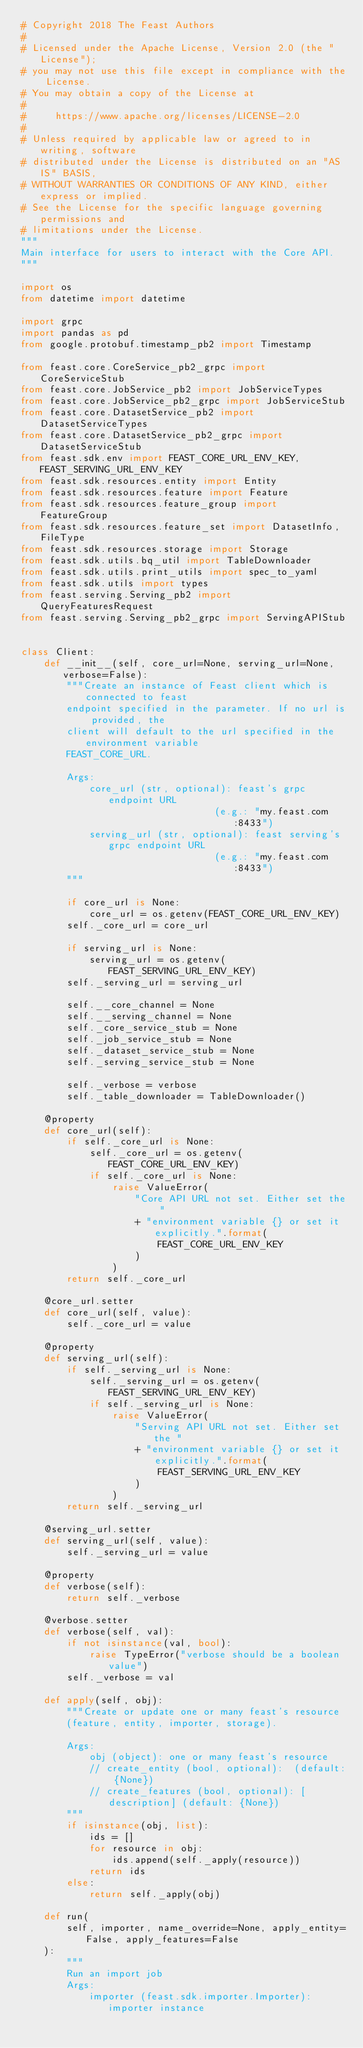Convert code to text. <code><loc_0><loc_0><loc_500><loc_500><_Python_># Copyright 2018 The Feast Authors
#
# Licensed under the Apache License, Version 2.0 (the "License");
# you may not use this file except in compliance with the License.
# You may obtain a copy of the License at
#
#     https://www.apache.org/licenses/LICENSE-2.0
#
# Unless required by applicable law or agreed to in writing, software
# distributed under the License is distributed on an "AS IS" BASIS,
# WITHOUT WARRANTIES OR CONDITIONS OF ANY KIND, either express or implied.
# See the License for the specific language governing permissions and
# limitations under the License.
"""
Main interface for users to interact with the Core API. 
"""

import os
from datetime import datetime

import grpc
import pandas as pd
from google.protobuf.timestamp_pb2 import Timestamp

from feast.core.CoreService_pb2_grpc import CoreServiceStub
from feast.core.JobService_pb2 import JobServiceTypes
from feast.core.JobService_pb2_grpc import JobServiceStub
from feast.core.DatasetService_pb2 import DatasetServiceTypes
from feast.core.DatasetService_pb2_grpc import DatasetServiceStub
from feast.sdk.env import FEAST_CORE_URL_ENV_KEY, FEAST_SERVING_URL_ENV_KEY
from feast.sdk.resources.entity import Entity
from feast.sdk.resources.feature import Feature
from feast.sdk.resources.feature_group import FeatureGroup
from feast.sdk.resources.feature_set import DatasetInfo, FileType
from feast.sdk.resources.storage import Storage
from feast.sdk.utils.bq_util import TableDownloader
from feast.sdk.utils.print_utils import spec_to_yaml
from feast.sdk.utils import types
from feast.serving.Serving_pb2 import QueryFeaturesRequest
from feast.serving.Serving_pb2_grpc import ServingAPIStub


class Client:
    def __init__(self, core_url=None, serving_url=None, verbose=False):
        """Create an instance of Feast client which is connected to feast
        endpoint specified in the parameter. If no url is provided, the
        client will default to the url specified in the environment variable
        FEAST_CORE_URL.

        Args:
            core_url (str, optional): feast's grpc endpoint URL
                                  (e.g.: "my.feast.com:8433")
            serving_url (str, optional): feast serving's grpc endpoint URL
                                  (e.g.: "my.feast.com:8433")
        """

        if core_url is None:
            core_url = os.getenv(FEAST_CORE_URL_ENV_KEY)
        self._core_url = core_url

        if serving_url is None:
            serving_url = os.getenv(FEAST_SERVING_URL_ENV_KEY)
        self._serving_url = serving_url

        self.__core_channel = None
        self.__serving_channel = None
        self._core_service_stub = None
        self._job_service_stub = None
        self._dataset_service_stub = None
        self._serving_service_stub = None

        self._verbose = verbose
        self._table_downloader = TableDownloader()

    @property
    def core_url(self):
        if self._core_url is None:
            self._core_url = os.getenv(FEAST_CORE_URL_ENV_KEY)
            if self._core_url is None:
                raise ValueError(
                    "Core API URL not set. Either set the "
                    + "environment variable {} or set it explicitly.".format(
                        FEAST_CORE_URL_ENV_KEY
                    )
                )
        return self._core_url

    @core_url.setter
    def core_url(self, value):
        self._core_url = value

    @property
    def serving_url(self):
        if self._serving_url is None:
            self._serving_url = os.getenv(FEAST_SERVING_URL_ENV_KEY)
            if self._serving_url is None:
                raise ValueError(
                    "Serving API URL not set. Either set the "
                    + "environment variable {} or set it explicitly.".format(
                        FEAST_SERVING_URL_ENV_KEY
                    )
                )
        return self._serving_url

    @serving_url.setter
    def serving_url(self, value):
        self._serving_url = value

    @property
    def verbose(self):
        return self._verbose

    @verbose.setter
    def verbose(self, val):
        if not isinstance(val, bool):
            raise TypeError("verbose should be a boolean value")
        self._verbose = val

    def apply(self, obj):
        """Create or update one or many feast's resource
        (feature, entity, importer, storage).

        Args:
            obj (object): one or many feast's resource
            // create_entity (bool, optional):  (default: {None})
            // create_features (bool, optional): [description] (default: {None})
        """
        if isinstance(obj, list):
            ids = []
            for resource in obj:
                ids.append(self._apply(resource))
            return ids
        else:
            return self._apply(obj)

    def run(
        self, importer, name_override=None, apply_entity=False, apply_features=False
    ):
        """
        Run an import job
        Args:
            importer (feast.sdk.importer.Importer): importer instance</code> 